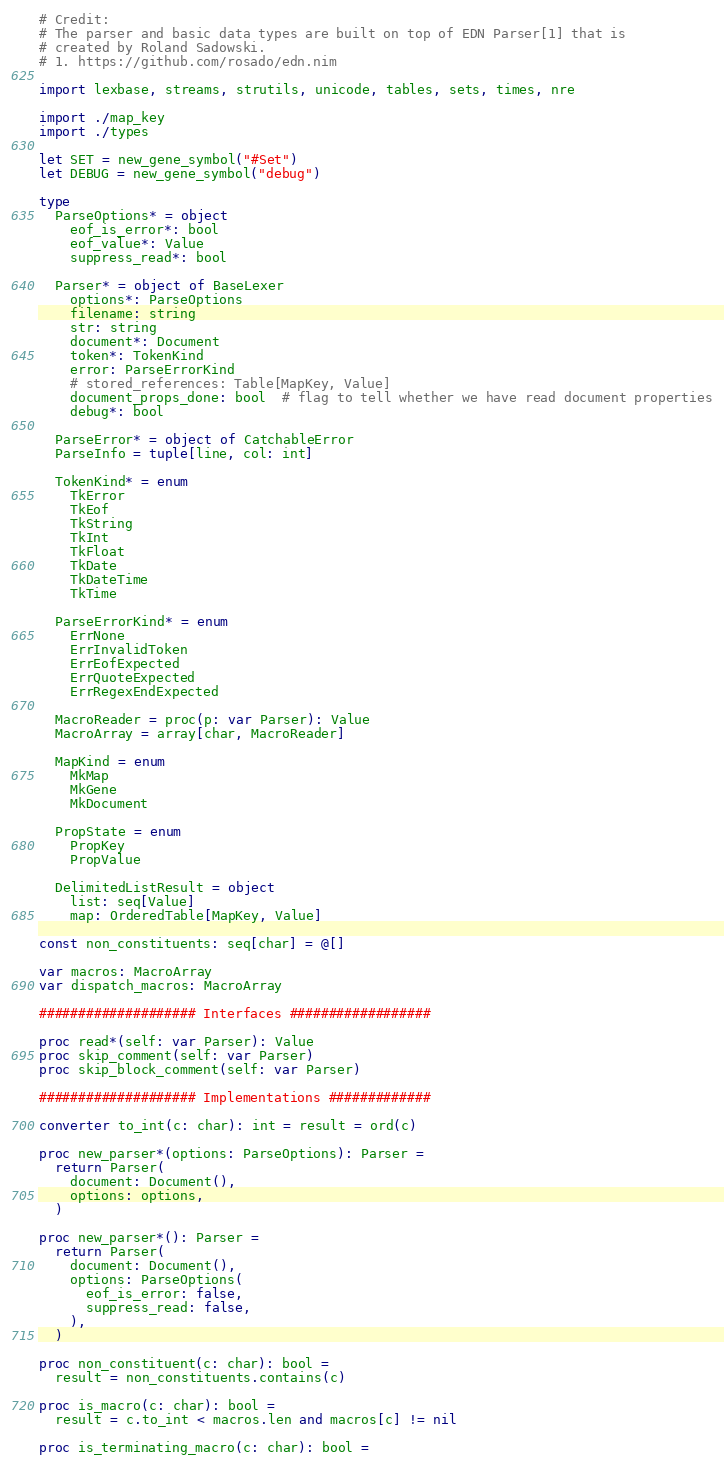<code> <loc_0><loc_0><loc_500><loc_500><_Nim_># Credit:
# The parser and basic data types are built on top of EDN Parser[1] that is
# created by Roland Sadowski.
# 1. https://github.com/rosado/edn.nim

import lexbase, streams, strutils, unicode, tables, sets, times, nre

import ./map_key
import ./types

let SET = new_gene_symbol("#Set")
let DEBUG = new_gene_symbol("debug")

type
  ParseOptions* = object
    eof_is_error*: bool
    eof_value*: Value
    suppress_read*: bool

  Parser* = object of BaseLexer
    options*: ParseOptions
    filename: string
    str: string
    document*: Document
    token*: TokenKind
    error: ParseErrorKind
    # stored_references: Table[MapKey, Value]
    document_props_done: bool  # flag to tell whether we have read document properties
    debug*: bool

  ParseError* = object of CatchableError
  ParseInfo = tuple[line, col: int]

  TokenKind* = enum
    TkError
    TkEof
    TkString
    TkInt
    TkFloat
    TkDate
    TkDateTime
    TkTime

  ParseErrorKind* = enum
    ErrNone
    ErrInvalidToken
    ErrEofExpected
    ErrQuoteExpected
    ErrRegexEndExpected

  MacroReader = proc(p: var Parser): Value
  MacroArray = array[char, MacroReader]

  MapKind = enum
    MkMap
    MkGene
    MkDocument

  PropState = enum
    PropKey
    PropValue

  DelimitedListResult = object
    list: seq[Value]
    map: OrderedTable[MapKey, Value]

const non_constituents: seq[char] = @[]

var macros: MacroArray
var dispatch_macros: MacroArray

#################### Interfaces ##################

proc read*(self: var Parser): Value
proc skip_comment(self: var Parser)
proc skip_block_comment(self: var Parser)

#################### Implementations #############

converter to_int(c: char): int = result = ord(c)

proc new_parser*(options: ParseOptions): Parser =
  return Parser(
    document: Document(),
    options: options,
  )

proc new_parser*(): Parser =
  return Parser(
    document: Document(),
    options: ParseOptions(
      eof_is_error: false,
      suppress_read: false,
    ),
  )

proc non_constituent(c: char): bool =
  result = non_constituents.contains(c)

proc is_macro(c: char): bool =
  result = c.to_int < macros.len and macros[c] != nil

proc is_terminating_macro(c: char): bool =</code> 